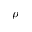<formula> <loc_0><loc_0><loc_500><loc_500>\rho</formula> 